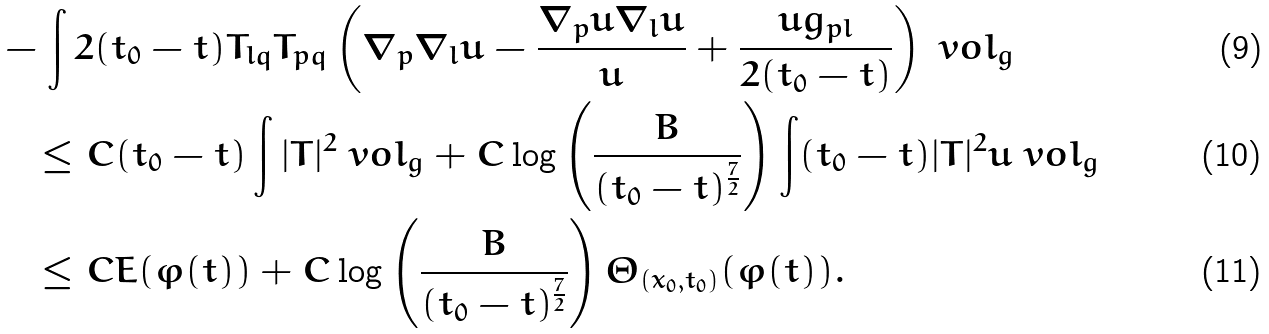Convert formula to latex. <formula><loc_0><loc_0><loc_500><loc_500>& - \int 2 ( t _ { 0 } - t ) T _ { l q } T _ { p q } \left ( \nabla _ { p } \nabla _ { l } u - \frac { \nabla _ { p } u \nabla _ { l } u } { u } + \frac { u g _ { p l } } { 2 ( t _ { 0 } - t ) } \right ) \ v o l _ { g } \\ & \quad \leq C ( t _ { 0 } - t ) \int | T | ^ { 2 } \ v o l _ { g } + C \log \left ( \frac { B } { ( t _ { 0 } - t ) ^ { \frac { 7 } { 2 } } } \right ) \int ( t _ { 0 } - t ) | T | ^ { 2 } u \ v o l _ { g } \\ & \quad \leq C E ( \varphi ( t ) ) + C \log \left ( \frac { B } { ( t _ { 0 } - t ) ^ { \frac { 7 } { 2 } } } \right ) \Theta _ { ( x _ { 0 } , t _ { 0 } ) } ( \varphi ( t ) ) .</formula> 